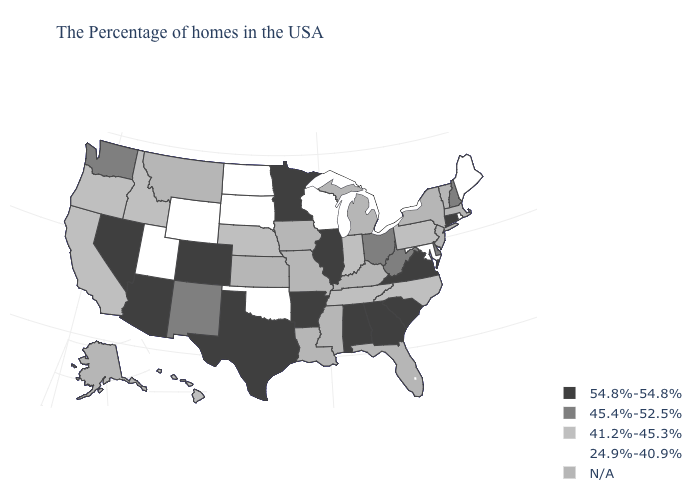What is the value of Illinois?
Write a very short answer. 54.8%-54.8%. What is the value of Louisiana?
Write a very short answer. N/A. Name the states that have a value in the range 54.8%-54.8%?
Give a very brief answer. Connecticut, Virginia, South Carolina, Georgia, Alabama, Illinois, Arkansas, Minnesota, Texas, Colorado, Arizona, Nevada. What is the lowest value in the USA?
Give a very brief answer. 24.9%-40.9%. Does Connecticut have the highest value in the Northeast?
Be succinct. Yes. Which states have the lowest value in the USA?
Quick response, please. Maine, Rhode Island, Maryland, Wisconsin, Oklahoma, South Dakota, North Dakota, Wyoming, Utah. Which states have the lowest value in the MidWest?
Concise answer only. Wisconsin, South Dakota, North Dakota. What is the value of New Hampshire?
Quick response, please. 45.4%-52.5%. What is the value of New York?
Give a very brief answer. N/A. What is the value of Maine?
Short answer required. 24.9%-40.9%. Name the states that have a value in the range 41.2%-45.3%?
Be succinct. Pennsylvania, North Carolina, Indiana, Tennessee, Nebraska, Idaho, California, Oregon, Hawaii. Name the states that have a value in the range 41.2%-45.3%?
Write a very short answer. Pennsylvania, North Carolina, Indiana, Tennessee, Nebraska, Idaho, California, Oregon, Hawaii. What is the highest value in states that border Tennessee?
Concise answer only. 54.8%-54.8%. Does Ohio have the lowest value in the MidWest?
Answer briefly. No. Name the states that have a value in the range N/A?
Give a very brief answer. Massachusetts, Vermont, New York, New Jersey, Florida, Michigan, Kentucky, Mississippi, Louisiana, Missouri, Iowa, Kansas, Montana, Alaska. 